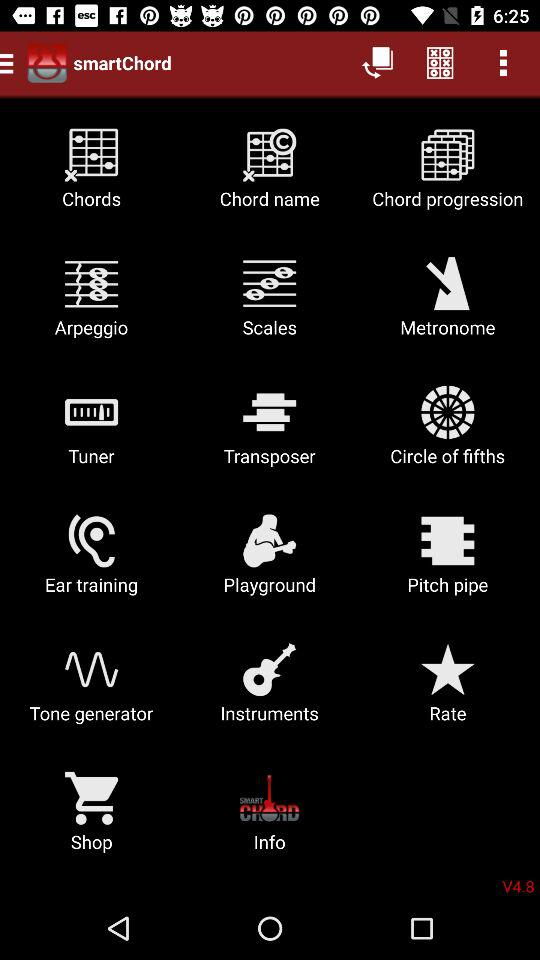What is the version of the app? The version of the app is V4.8. 